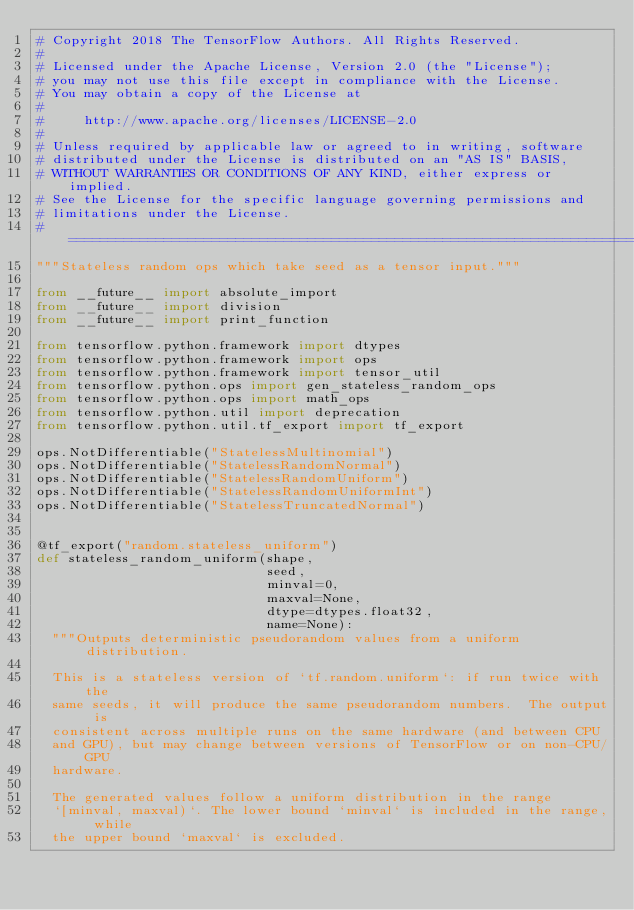<code> <loc_0><loc_0><loc_500><loc_500><_Python_># Copyright 2018 The TensorFlow Authors. All Rights Reserved.
#
# Licensed under the Apache License, Version 2.0 (the "License");
# you may not use this file except in compliance with the License.
# You may obtain a copy of the License at
#
#     http://www.apache.org/licenses/LICENSE-2.0
#
# Unless required by applicable law or agreed to in writing, software
# distributed under the License is distributed on an "AS IS" BASIS,
# WITHOUT WARRANTIES OR CONDITIONS OF ANY KIND, either express or implied.
# See the License for the specific language governing permissions and
# limitations under the License.
# ==============================================================================
"""Stateless random ops which take seed as a tensor input."""

from __future__ import absolute_import
from __future__ import division
from __future__ import print_function

from tensorflow.python.framework import dtypes
from tensorflow.python.framework import ops
from tensorflow.python.framework import tensor_util
from tensorflow.python.ops import gen_stateless_random_ops
from tensorflow.python.ops import math_ops
from tensorflow.python.util import deprecation
from tensorflow.python.util.tf_export import tf_export

ops.NotDifferentiable("StatelessMultinomial")
ops.NotDifferentiable("StatelessRandomNormal")
ops.NotDifferentiable("StatelessRandomUniform")
ops.NotDifferentiable("StatelessRandomUniformInt")
ops.NotDifferentiable("StatelessTruncatedNormal")


@tf_export("random.stateless_uniform")
def stateless_random_uniform(shape,
                             seed,
                             minval=0,
                             maxval=None,
                             dtype=dtypes.float32,
                             name=None):
  """Outputs deterministic pseudorandom values from a uniform distribution.

  This is a stateless version of `tf.random.uniform`: if run twice with the
  same seeds, it will produce the same pseudorandom numbers.  The output is
  consistent across multiple runs on the same hardware (and between CPU
  and GPU), but may change between versions of TensorFlow or on non-CPU/GPU
  hardware.

  The generated values follow a uniform distribution in the range
  `[minval, maxval)`. The lower bound `minval` is included in the range, while
  the upper bound `maxval` is excluded.
</code> 